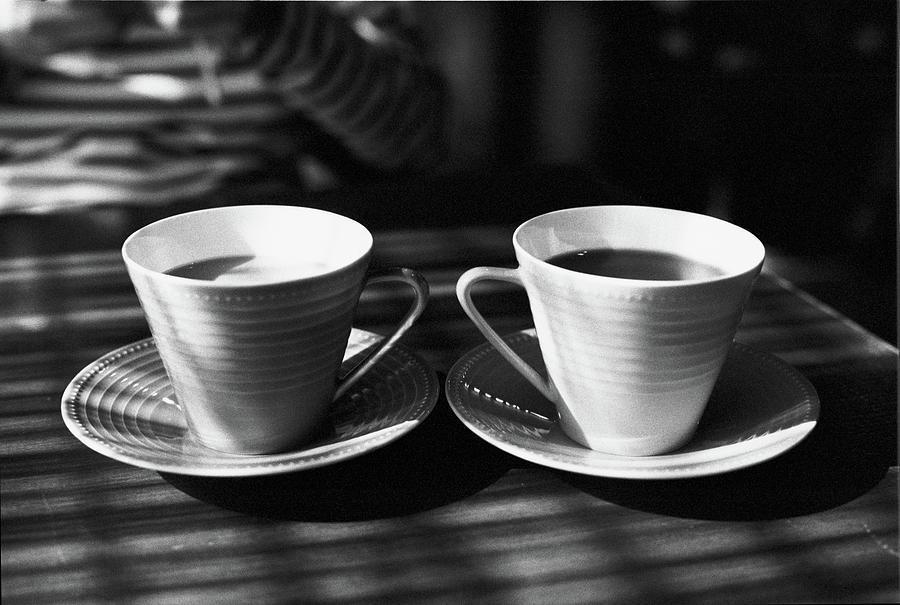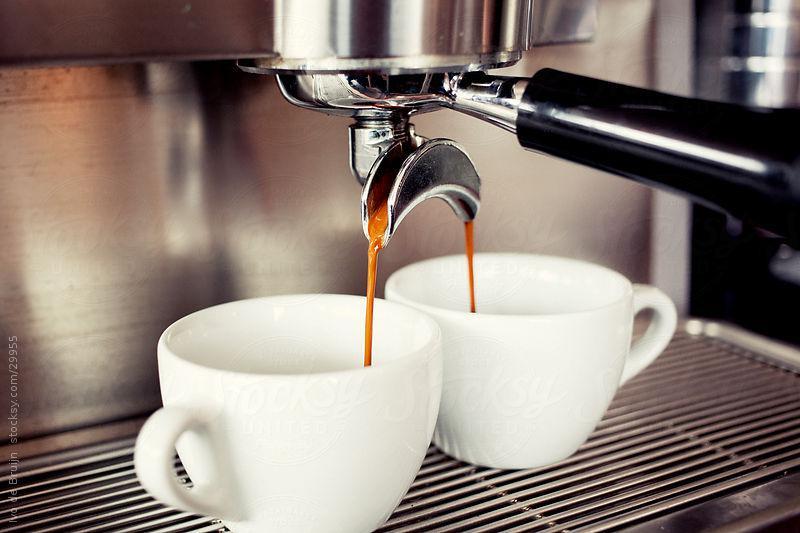The first image is the image on the left, the second image is the image on the right. For the images shown, is this caption "The two white cups in the image on the left are sitting in saucers." true? Answer yes or no. Yes. 